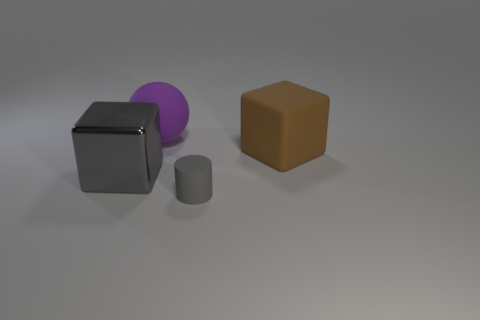Is the number of gray cylinders that are behind the metallic cube less than the number of large brown rubber cubes?
Make the answer very short. Yes. There is a large cube that is in front of the block on the right side of the gray thing that is right of the purple thing; what is it made of?
Keep it short and to the point. Metal. Is the number of cubes that are behind the big gray thing greater than the number of gray rubber cylinders right of the big rubber cube?
Provide a succinct answer. Yes. What number of metallic objects are cylinders or large green spheres?
Your answer should be very brief. 0. There is a big object that is the same color as the cylinder; what shape is it?
Offer a terse response. Cube. There is a block that is in front of the brown block; what material is it?
Give a very brief answer. Metal. How many things are tiny gray rubber objects or cubes that are behind the large gray metal object?
Offer a terse response. 2. There is a brown thing that is the same size as the gray shiny thing; what is its shape?
Your answer should be compact. Cube. What number of other large rubber spheres are the same color as the ball?
Your answer should be very brief. 0. Does the object that is behind the large brown block have the same material as the brown thing?
Offer a terse response. Yes. 